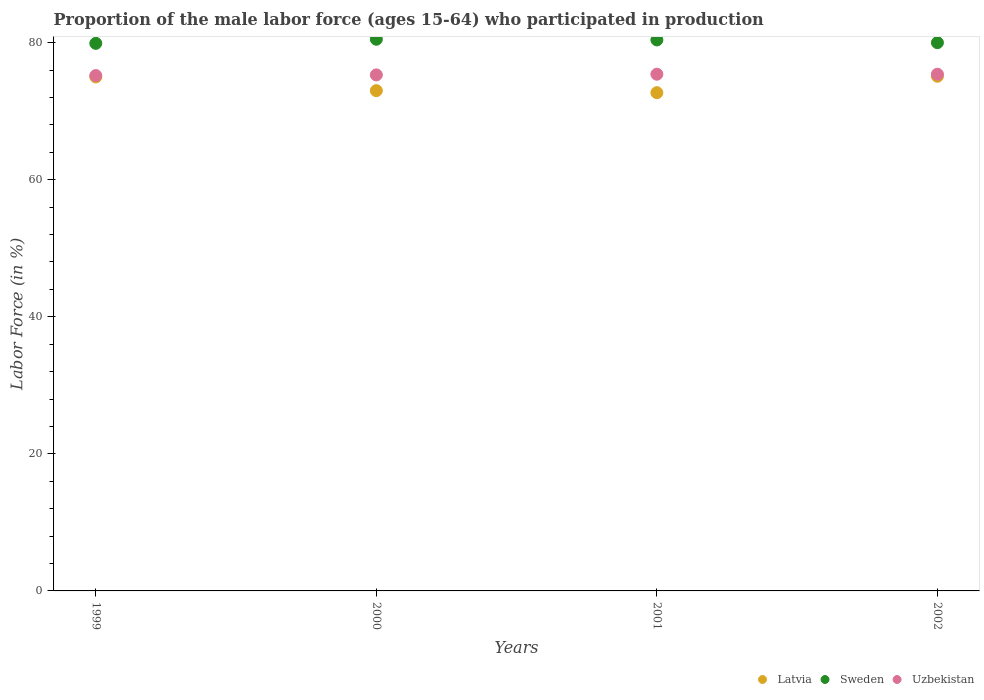What is the proportion of the male labor force who participated in production in Uzbekistan in 1999?
Offer a terse response. 75.2. Across all years, what is the maximum proportion of the male labor force who participated in production in Sweden?
Ensure brevity in your answer.  80.5. Across all years, what is the minimum proportion of the male labor force who participated in production in Uzbekistan?
Your response must be concise. 75.2. In which year was the proportion of the male labor force who participated in production in Uzbekistan minimum?
Offer a terse response. 1999. What is the total proportion of the male labor force who participated in production in Sweden in the graph?
Provide a succinct answer. 320.8. What is the difference between the proportion of the male labor force who participated in production in Sweden in 2000 and that in 2001?
Provide a short and direct response. 0.1. What is the difference between the proportion of the male labor force who participated in production in Uzbekistan in 2000 and the proportion of the male labor force who participated in production in Latvia in 2001?
Offer a very short reply. 2.6. What is the average proportion of the male labor force who participated in production in Uzbekistan per year?
Keep it short and to the point. 75.33. In the year 2002, what is the difference between the proportion of the male labor force who participated in production in Uzbekistan and proportion of the male labor force who participated in production in Latvia?
Your answer should be very brief. 0.3. In how many years, is the proportion of the male labor force who participated in production in Uzbekistan greater than 56 %?
Offer a terse response. 4. What is the ratio of the proportion of the male labor force who participated in production in Uzbekistan in 2001 to that in 2002?
Offer a very short reply. 1. Is the proportion of the male labor force who participated in production in Sweden in 1999 less than that in 2002?
Your response must be concise. Yes. Is the difference between the proportion of the male labor force who participated in production in Uzbekistan in 2000 and 2002 greater than the difference between the proportion of the male labor force who participated in production in Latvia in 2000 and 2002?
Give a very brief answer. Yes. What is the difference between the highest and the second highest proportion of the male labor force who participated in production in Latvia?
Make the answer very short. 0.1. What is the difference between the highest and the lowest proportion of the male labor force who participated in production in Sweden?
Your answer should be very brief. 0.6. Is the proportion of the male labor force who participated in production in Uzbekistan strictly greater than the proportion of the male labor force who participated in production in Latvia over the years?
Your response must be concise. Yes. How many dotlines are there?
Offer a very short reply. 3. How many years are there in the graph?
Offer a very short reply. 4. What is the difference between two consecutive major ticks on the Y-axis?
Your response must be concise. 20. Does the graph contain any zero values?
Your answer should be compact. No. Does the graph contain grids?
Provide a succinct answer. No. Where does the legend appear in the graph?
Ensure brevity in your answer.  Bottom right. How are the legend labels stacked?
Provide a short and direct response. Horizontal. What is the title of the graph?
Offer a very short reply. Proportion of the male labor force (ages 15-64) who participated in production. What is the label or title of the X-axis?
Ensure brevity in your answer.  Years. What is the label or title of the Y-axis?
Your answer should be compact. Labor Force (in %). What is the Labor Force (in %) in Latvia in 1999?
Give a very brief answer. 75. What is the Labor Force (in %) in Sweden in 1999?
Your response must be concise. 79.9. What is the Labor Force (in %) of Uzbekistan in 1999?
Your answer should be compact. 75.2. What is the Labor Force (in %) in Latvia in 2000?
Ensure brevity in your answer.  73. What is the Labor Force (in %) of Sweden in 2000?
Keep it short and to the point. 80.5. What is the Labor Force (in %) of Uzbekistan in 2000?
Provide a short and direct response. 75.3. What is the Labor Force (in %) in Latvia in 2001?
Provide a short and direct response. 72.7. What is the Labor Force (in %) in Sweden in 2001?
Your answer should be very brief. 80.4. What is the Labor Force (in %) of Uzbekistan in 2001?
Your answer should be compact. 75.4. What is the Labor Force (in %) of Latvia in 2002?
Ensure brevity in your answer.  75.1. What is the Labor Force (in %) in Uzbekistan in 2002?
Provide a succinct answer. 75.4. Across all years, what is the maximum Labor Force (in %) in Latvia?
Your answer should be very brief. 75.1. Across all years, what is the maximum Labor Force (in %) of Sweden?
Ensure brevity in your answer.  80.5. Across all years, what is the maximum Labor Force (in %) of Uzbekistan?
Offer a terse response. 75.4. Across all years, what is the minimum Labor Force (in %) of Latvia?
Offer a terse response. 72.7. Across all years, what is the minimum Labor Force (in %) in Sweden?
Offer a very short reply. 79.9. Across all years, what is the minimum Labor Force (in %) of Uzbekistan?
Give a very brief answer. 75.2. What is the total Labor Force (in %) of Latvia in the graph?
Offer a very short reply. 295.8. What is the total Labor Force (in %) in Sweden in the graph?
Your answer should be compact. 320.8. What is the total Labor Force (in %) in Uzbekistan in the graph?
Offer a very short reply. 301.3. What is the difference between the Labor Force (in %) in Latvia in 1999 and that in 2000?
Offer a very short reply. 2. What is the difference between the Labor Force (in %) of Uzbekistan in 1999 and that in 2000?
Give a very brief answer. -0.1. What is the difference between the Labor Force (in %) in Sweden in 1999 and that in 2001?
Provide a succinct answer. -0.5. What is the difference between the Labor Force (in %) in Uzbekistan in 1999 and that in 2001?
Make the answer very short. -0.2. What is the difference between the Labor Force (in %) in Latvia in 1999 and that in 2002?
Provide a short and direct response. -0.1. What is the difference between the Labor Force (in %) in Sweden in 1999 and that in 2002?
Offer a very short reply. -0.1. What is the difference between the Labor Force (in %) in Uzbekistan in 1999 and that in 2002?
Offer a very short reply. -0.2. What is the difference between the Labor Force (in %) in Latvia in 2000 and that in 2001?
Keep it short and to the point. 0.3. What is the difference between the Labor Force (in %) of Sweden in 2000 and that in 2001?
Offer a terse response. 0.1. What is the difference between the Labor Force (in %) in Latvia in 2001 and that in 2002?
Provide a succinct answer. -2.4. What is the difference between the Labor Force (in %) in Latvia in 1999 and the Labor Force (in %) in Uzbekistan in 2001?
Offer a terse response. -0.4. What is the difference between the Labor Force (in %) in Latvia in 1999 and the Labor Force (in %) in Uzbekistan in 2002?
Keep it short and to the point. -0.4. What is the difference between the Labor Force (in %) of Sweden in 1999 and the Labor Force (in %) of Uzbekistan in 2002?
Keep it short and to the point. 4.5. What is the difference between the Labor Force (in %) in Latvia in 2000 and the Labor Force (in %) in Sweden in 2001?
Give a very brief answer. -7.4. What is the difference between the Labor Force (in %) in Latvia in 2000 and the Labor Force (in %) in Uzbekistan in 2001?
Your response must be concise. -2.4. What is the difference between the Labor Force (in %) in Latvia in 2000 and the Labor Force (in %) in Uzbekistan in 2002?
Ensure brevity in your answer.  -2.4. What is the difference between the Labor Force (in %) in Sweden in 2000 and the Labor Force (in %) in Uzbekistan in 2002?
Your response must be concise. 5.1. What is the difference between the Labor Force (in %) in Latvia in 2001 and the Labor Force (in %) in Sweden in 2002?
Offer a terse response. -7.3. What is the difference between the Labor Force (in %) of Latvia in 2001 and the Labor Force (in %) of Uzbekistan in 2002?
Your answer should be very brief. -2.7. What is the difference between the Labor Force (in %) of Sweden in 2001 and the Labor Force (in %) of Uzbekistan in 2002?
Offer a terse response. 5. What is the average Labor Force (in %) of Latvia per year?
Your answer should be compact. 73.95. What is the average Labor Force (in %) in Sweden per year?
Keep it short and to the point. 80.2. What is the average Labor Force (in %) in Uzbekistan per year?
Ensure brevity in your answer.  75.33. In the year 1999, what is the difference between the Labor Force (in %) in Sweden and Labor Force (in %) in Uzbekistan?
Provide a short and direct response. 4.7. In the year 2000, what is the difference between the Labor Force (in %) in Latvia and Labor Force (in %) in Sweden?
Ensure brevity in your answer.  -7.5. In the year 2000, what is the difference between the Labor Force (in %) in Latvia and Labor Force (in %) in Uzbekistan?
Make the answer very short. -2.3. In the year 2000, what is the difference between the Labor Force (in %) of Sweden and Labor Force (in %) of Uzbekistan?
Ensure brevity in your answer.  5.2. In the year 2001, what is the difference between the Labor Force (in %) in Latvia and Labor Force (in %) in Uzbekistan?
Your response must be concise. -2.7. In the year 2002, what is the difference between the Labor Force (in %) in Latvia and Labor Force (in %) in Sweden?
Your answer should be compact. -4.9. What is the ratio of the Labor Force (in %) of Latvia in 1999 to that in 2000?
Provide a short and direct response. 1.03. What is the ratio of the Labor Force (in %) in Latvia in 1999 to that in 2001?
Provide a short and direct response. 1.03. What is the ratio of the Labor Force (in %) of Sweden in 1999 to that in 2001?
Your response must be concise. 0.99. What is the ratio of the Labor Force (in %) of Uzbekistan in 1999 to that in 2002?
Give a very brief answer. 1. What is the ratio of the Labor Force (in %) in Sweden in 2000 to that in 2001?
Your answer should be very brief. 1. What is the ratio of the Labor Force (in %) in Uzbekistan in 2000 to that in 2001?
Your response must be concise. 1. What is the ratio of the Labor Force (in %) of Latvia in 2000 to that in 2002?
Keep it short and to the point. 0.97. What is the ratio of the Labor Force (in %) of Sweden in 2000 to that in 2002?
Give a very brief answer. 1.01. What is the ratio of the Labor Force (in %) of Latvia in 2001 to that in 2002?
Offer a terse response. 0.97. What is the ratio of the Labor Force (in %) in Sweden in 2001 to that in 2002?
Offer a terse response. 1. What is the ratio of the Labor Force (in %) of Uzbekistan in 2001 to that in 2002?
Your answer should be very brief. 1. What is the difference between the highest and the lowest Labor Force (in %) in Sweden?
Ensure brevity in your answer.  0.6. What is the difference between the highest and the lowest Labor Force (in %) of Uzbekistan?
Your answer should be very brief. 0.2. 